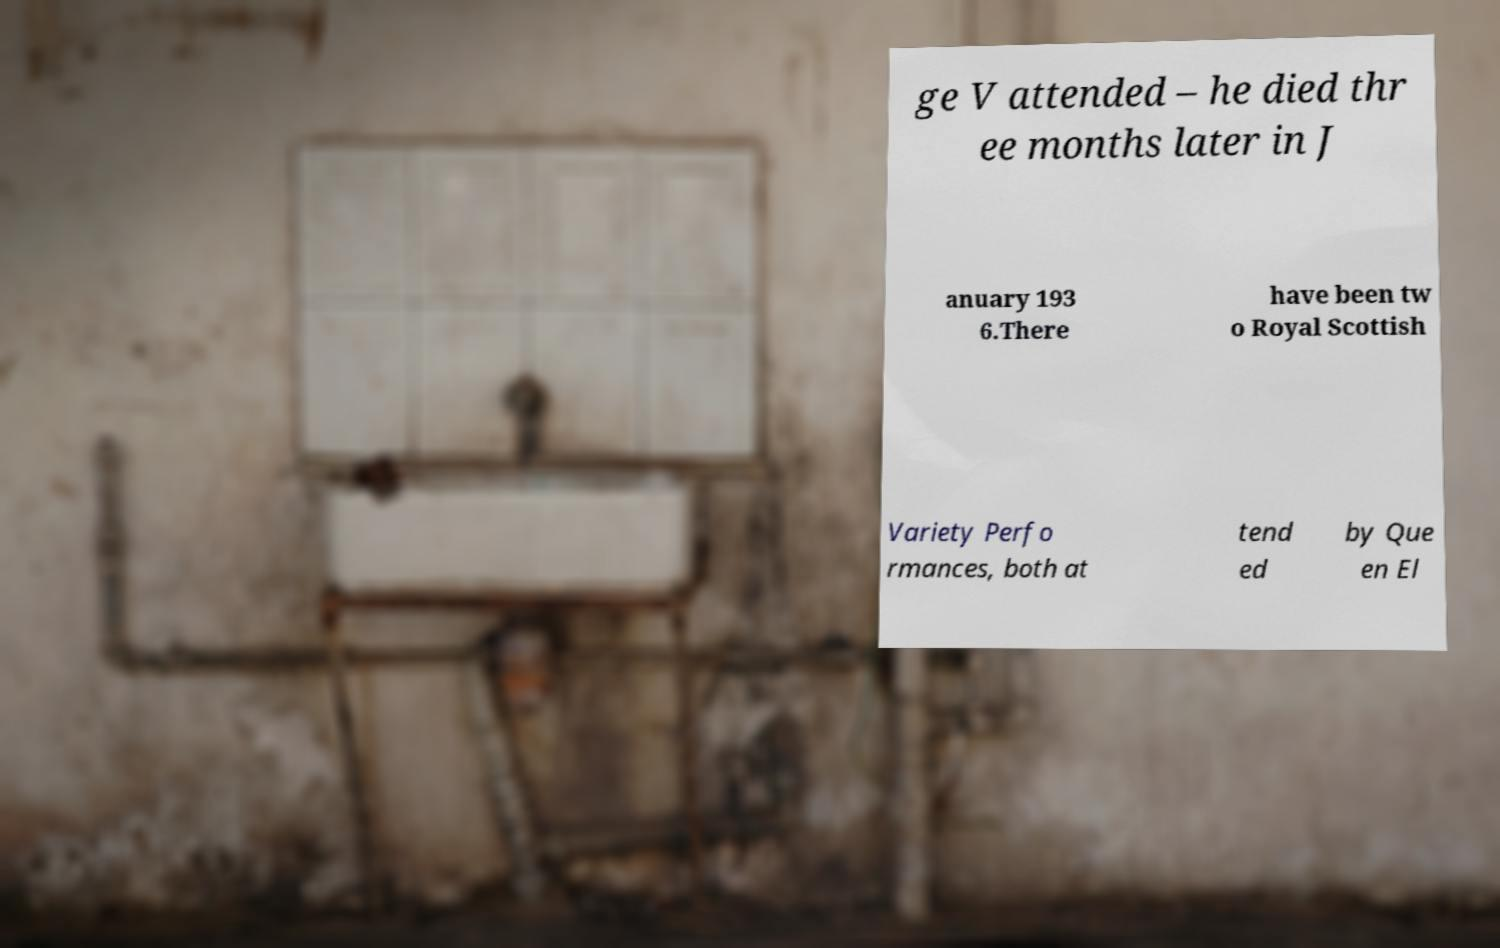There's text embedded in this image that I need extracted. Can you transcribe it verbatim? ge V attended – he died thr ee months later in J anuary 193 6.There have been tw o Royal Scottish Variety Perfo rmances, both at tend ed by Que en El 